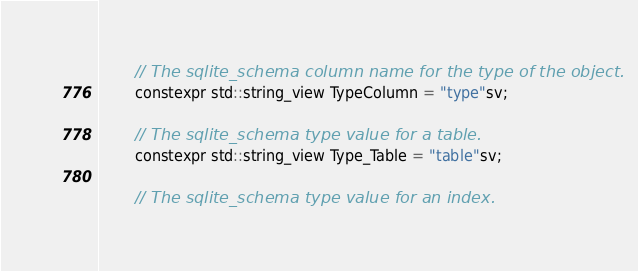Convert code to text. <code><loc_0><loc_0><loc_500><loc_500><_C_>
        // The sqlite_schema column name for the type of the object.
        constexpr std::string_view TypeColumn = "type"sv;

        // The sqlite_schema type value for a table.
        constexpr std::string_view Type_Table = "table"sv;

        // The sqlite_schema type value for an index.</code> 